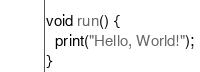<code> <loc_0><loc_0><loc_500><loc_500><_Ceylon_>void run() {
  print("Hello, World!");
}
</code> 